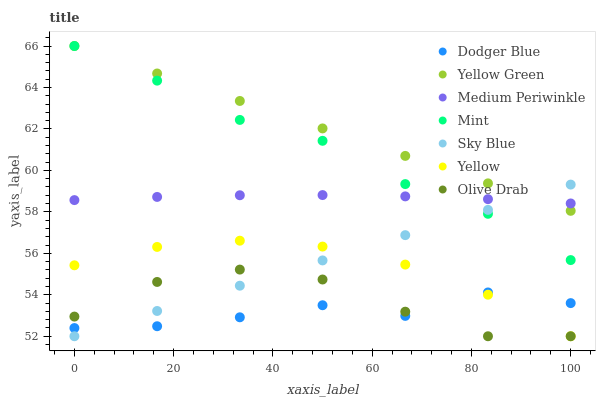Does Dodger Blue have the minimum area under the curve?
Answer yes or no. Yes. Does Yellow Green have the maximum area under the curve?
Answer yes or no. Yes. Does Medium Periwinkle have the minimum area under the curve?
Answer yes or no. No. Does Medium Periwinkle have the maximum area under the curve?
Answer yes or no. No. Is Sky Blue the smoothest?
Answer yes or no. Yes. Is Dodger Blue the roughest?
Answer yes or no. Yes. Is Medium Periwinkle the smoothest?
Answer yes or no. No. Is Medium Periwinkle the roughest?
Answer yes or no. No. Does Yellow have the lowest value?
Answer yes or no. Yes. Does Medium Periwinkle have the lowest value?
Answer yes or no. No. Does Mint have the highest value?
Answer yes or no. Yes. Does Medium Periwinkle have the highest value?
Answer yes or no. No. Is Dodger Blue less than Medium Periwinkle?
Answer yes or no. Yes. Is Yellow Green greater than Yellow?
Answer yes or no. Yes. Does Yellow intersect Olive Drab?
Answer yes or no. Yes. Is Yellow less than Olive Drab?
Answer yes or no. No. Is Yellow greater than Olive Drab?
Answer yes or no. No. Does Dodger Blue intersect Medium Periwinkle?
Answer yes or no. No. 